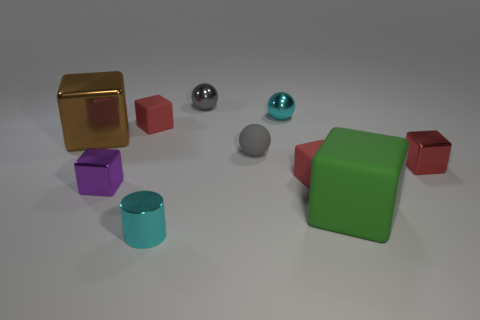What material is the object that is the same color as the tiny cylinder?
Offer a terse response. Metal. What number of balls have the same size as the purple thing?
Provide a short and direct response. 3. Is the material of the object on the left side of the tiny purple shiny block the same as the cylinder?
Ensure brevity in your answer.  Yes. There is a gray metallic thing that is behind the cyan cylinder; is there a small rubber sphere behind it?
Make the answer very short. No. There is a green thing that is the same shape as the tiny purple metallic thing; what material is it?
Your response must be concise. Rubber. Is the number of large brown objects that are behind the brown block greater than the number of cyan metallic spheres left of the cyan metallic ball?
Offer a terse response. No. What shape is the gray object that is made of the same material as the large green thing?
Your response must be concise. Sphere. Is the number of big green rubber blocks that are on the right side of the small metal cylinder greater than the number of small brown cylinders?
Give a very brief answer. Yes. What number of objects have the same color as the matte sphere?
Make the answer very short. 1. What number of other objects are there of the same color as the large metallic object?
Offer a very short reply. 0. 